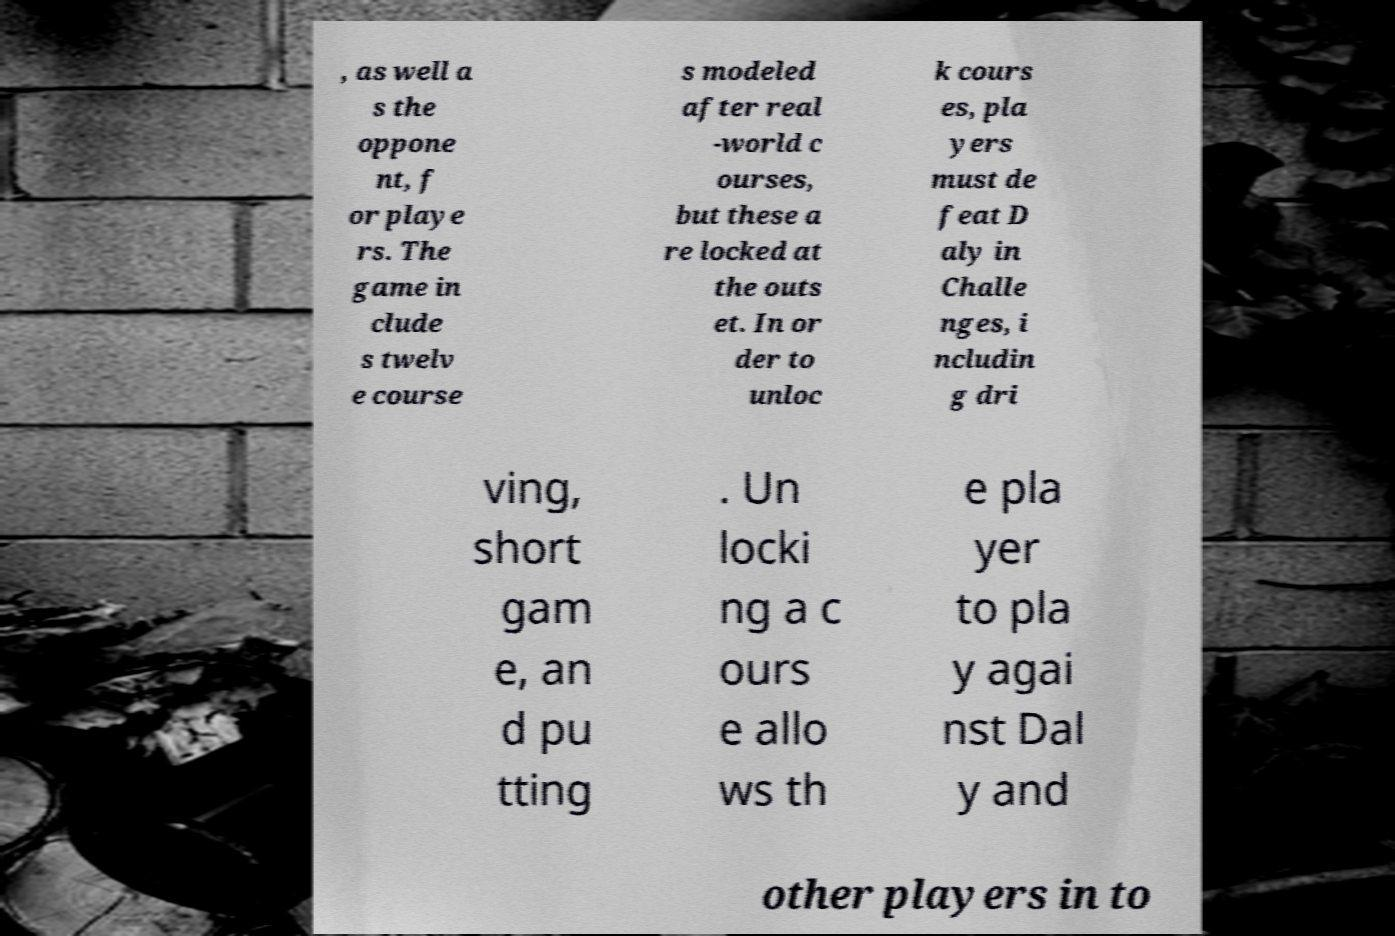There's text embedded in this image that I need extracted. Can you transcribe it verbatim? , as well a s the oppone nt, f or playe rs. The game in clude s twelv e course s modeled after real -world c ourses, but these a re locked at the outs et. In or der to unloc k cours es, pla yers must de feat D aly in Challe nges, i ncludin g dri ving, short gam e, an d pu tting . Un locki ng a c ours e allo ws th e pla yer to pla y agai nst Dal y and other players in to 